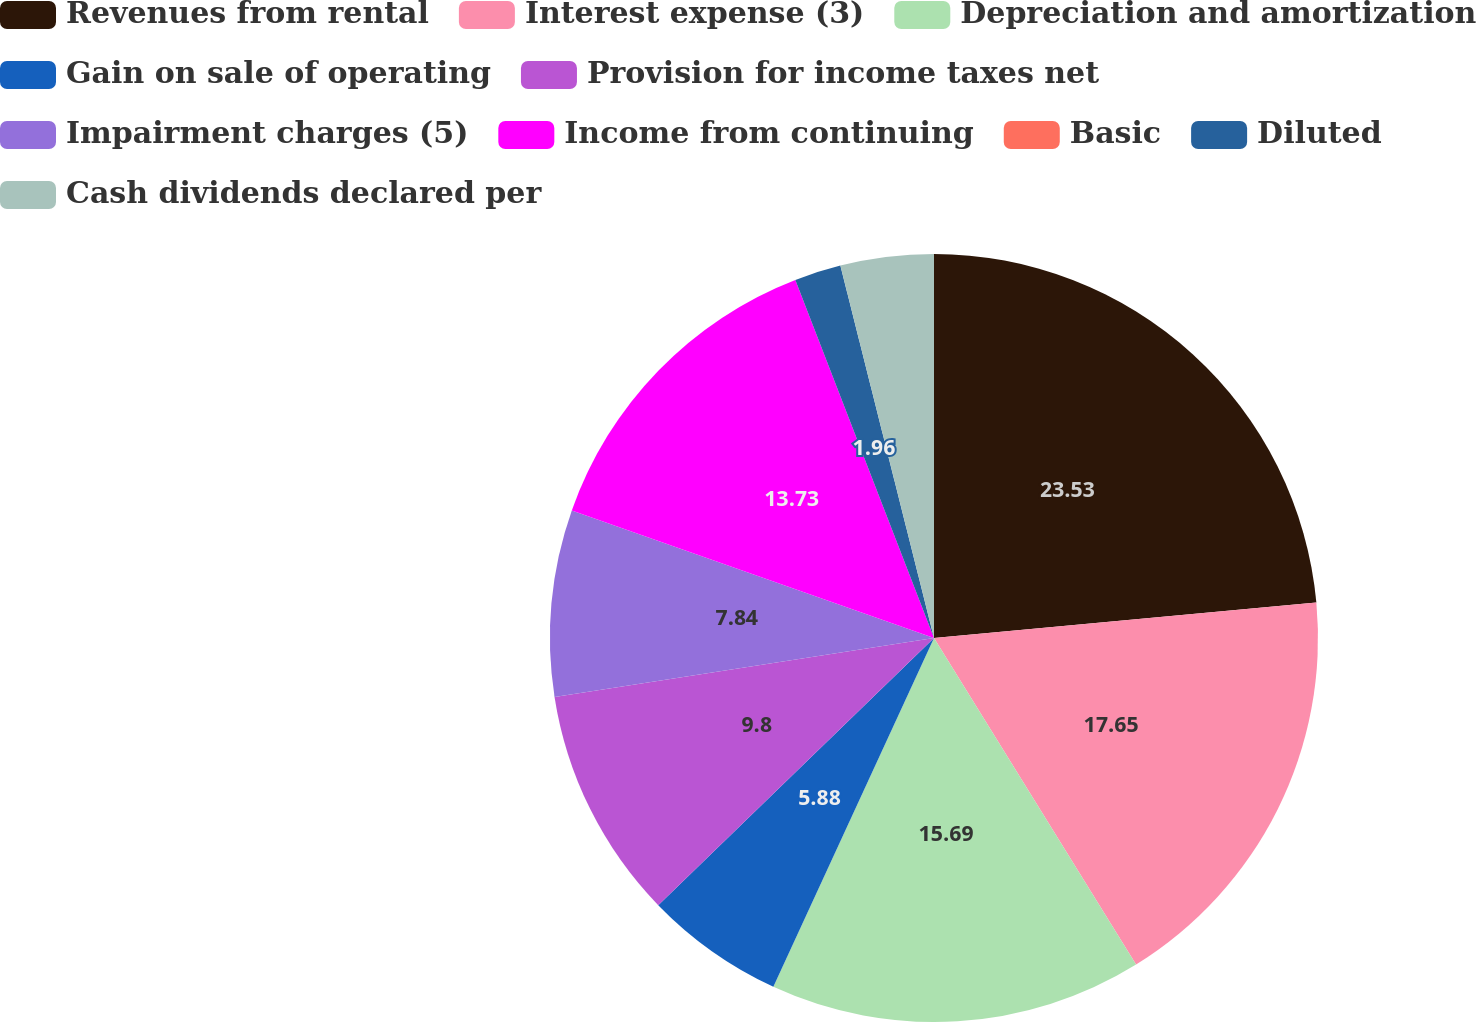Convert chart. <chart><loc_0><loc_0><loc_500><loc_500><pie_chart><fcel>Revenues from rental<fcel>Interest expense (3)<fcel>Depreciation and amortization<fcel>Gain on sale of operating<fcel>Provision for income taxes net<fcel>Impairment charges (5)<fcel>Income from continuing<fcel>Basic<fcel>Diluted<fcel>Cash dividends declared per<nl><fcel>23.53%<fcel>17.65%<fcel>15.69%<fcel>5.88%<fcel>9.8%<fcel>7.84%<fcel>13.73%<fcel>0.0%<fcel>1.96%<fcel>3.92%<nl></chart> 